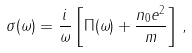<formula> <loc_0><loc_0><loc_500><loc_500>\sigma ( \omega ) = \frac { i } { \omega } \left [ \Pi ( \omega ) + \frac { n _ { 0 } e ^ { 2 } } { m } \right ] \, ,</formula> 